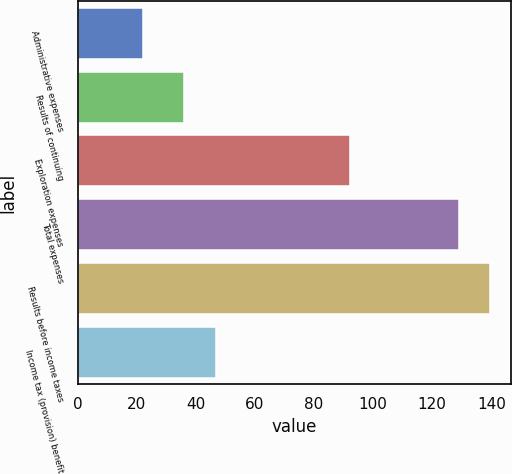Convert chart. <chart><loc_0><loc_0><loc_500><loc_500><bar_chart><fcel>Administrative expenses<fcel>Results of continuing<fcel>Exploration expenses<fcel>Total expenses<fcel>Results before income taxes<fcel>Income tax (provision) benefit<nl><fcel>22<fcel>36<fcel>92<fcel>129<fcel>139.7<fcel>46.7<nl></chart> 